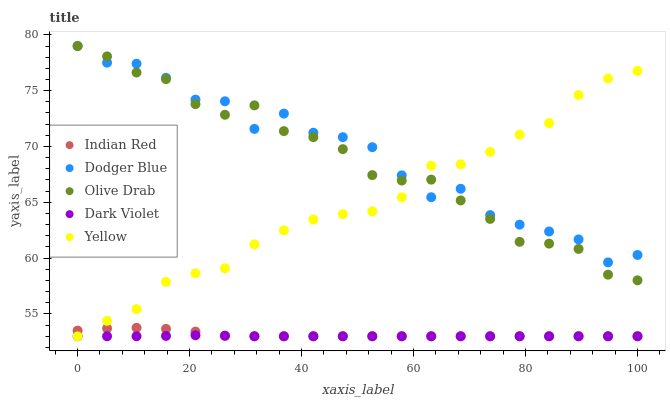Does Dark Violet have the minimum area under the curve?
Answer yes or no. Yes. Does Dodger Blue have the maximum area under the curve?
Answer yes or no. Yes. Does Yellow have the minimum area under the curve?
Answer yes or no. No. Does Yellow have the maximum area under the curve?
Answer yes or no. No. Is Dark Violet the smoothest?
Answer yes or no. Yes. Is Dodger Blue the roughest?
Answer yes or no. Yes. Is Yellow the smoothest?
Answer yes or no. No. Is Yellow the roughest?
Answer yes or no. No. Does Dark Violet have the lowest value?
Answer yes or no. Yes. Does Dodger Blue have the lowest value?
Answer yes or no. No. Does Olive Drab have the highest value?
Answer yes or no. Yes. Does Yellow have the highest value?
Answer yes or no. No. Is Dark Violet less than Dodger Blue?
Answer yes or no. Yes. Is Olive Drab greater than Indian Red?
Answer yes or no. Yes. Does Indian Red intersect Dark Violet?
Answer yes or no. Yes. Is Indian Red less than Dark Violet?
Answer yes or no. No. Is Indian Red greater than Dark Violet?
Answer yes or no. No. Does Dark Violet intersect Dodger Blue?
Answer yes or no. No. 